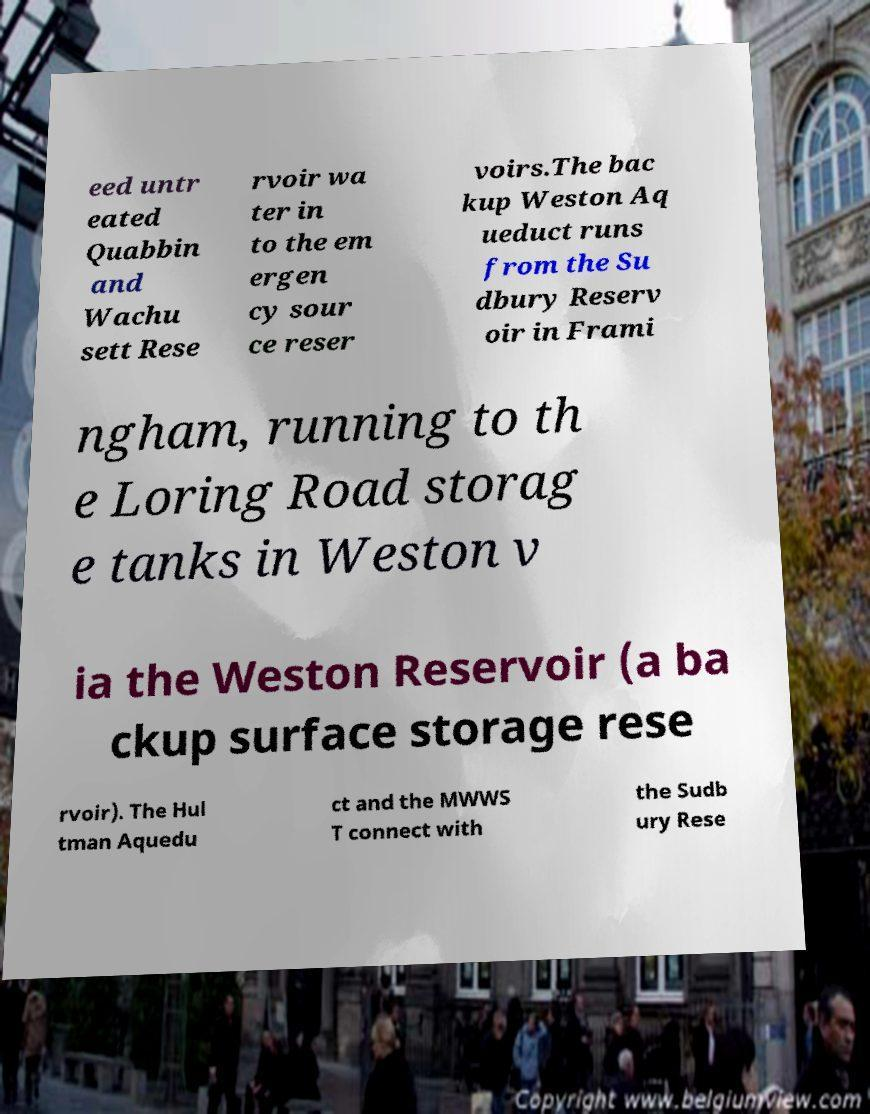Could you extract and type out the text from this image? eed untr eated Quabbin and Wachu sett Rese rvoir wa ter in to the em ergen cy sour ce reser voirs.The bac kup Weston Aq ueduct runs from the Su dbury Reserv oir in Frami ngham, running to th e Loring Road storag e tanks in Weston v ia the Weston Reservoir (a ba ckup surface storage rese rvoir). The Hul tman Aquedu ct and the MWWS T connect with the Sudb ury Rese 